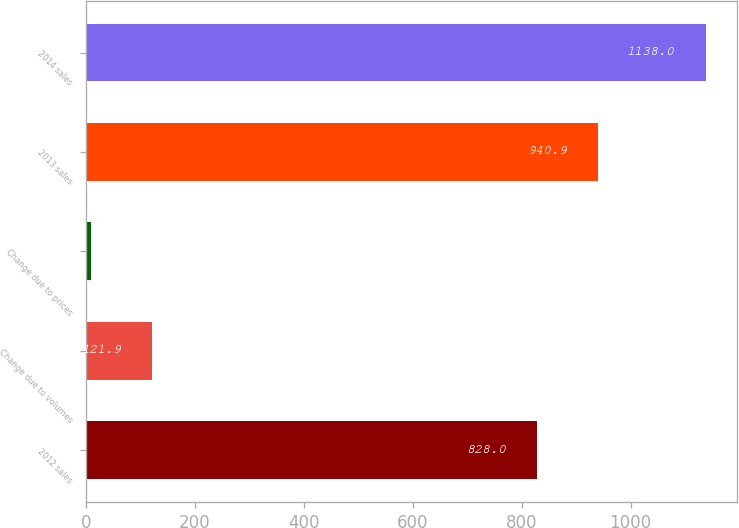Convert chart. <chart><loc_0><loc_0><loc_500><loc_500><bar_chart><fcel>2012 sales<fcel>Change due to volumes<fcel>Change due to prices<fcel>2013 sales<fcel>2014 sales<nl><fcel>828<fcel>121.9<fcel>9<fcel>940.9<fcel>1138<nl></chart> 